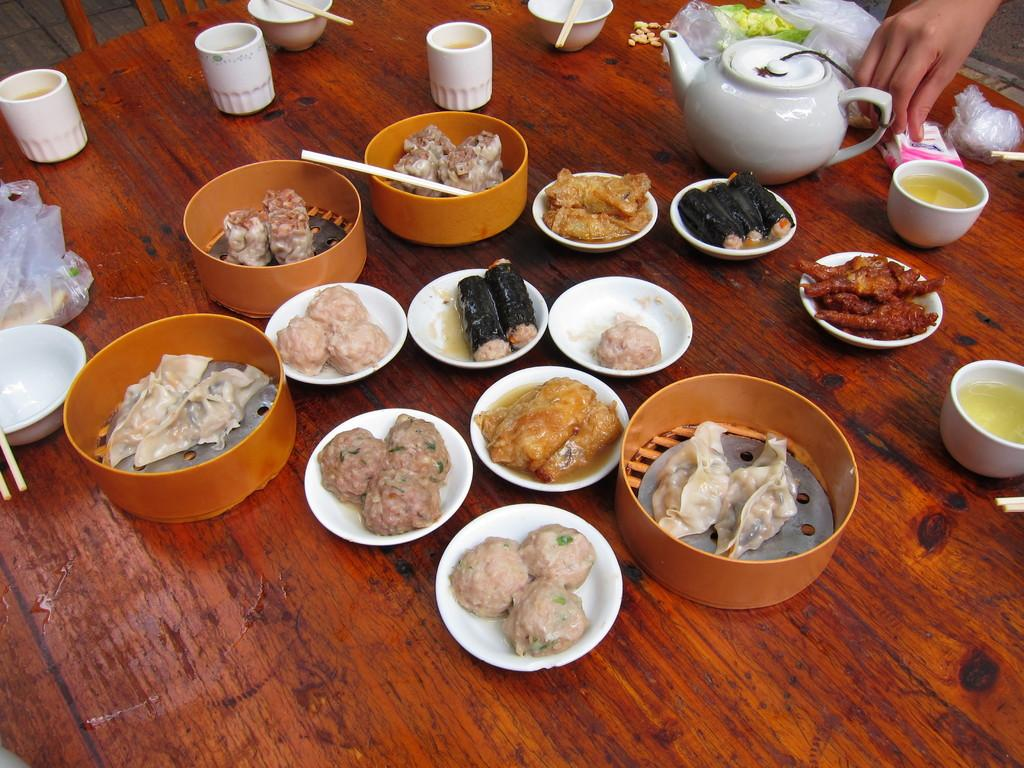What is the main piece of furniture in the image? There is a table in the image. What can be seen in the bowls on the table? There are different kinds of dishes placed in bowls on the table. What utensils are visible on the table? Chopsticks are visible on the table. What type of kitchen appliance is present on the table? There is a kettle on the table. What type of food is present on the table? Vegetables are present on the table. What type of covering is present on the table? Polythene covers are present on the table. What type of notebook is visible on the table in the image? There is no notebook present on the table in the image. What view can be seen through the window in the image? There is no window present in the image. 